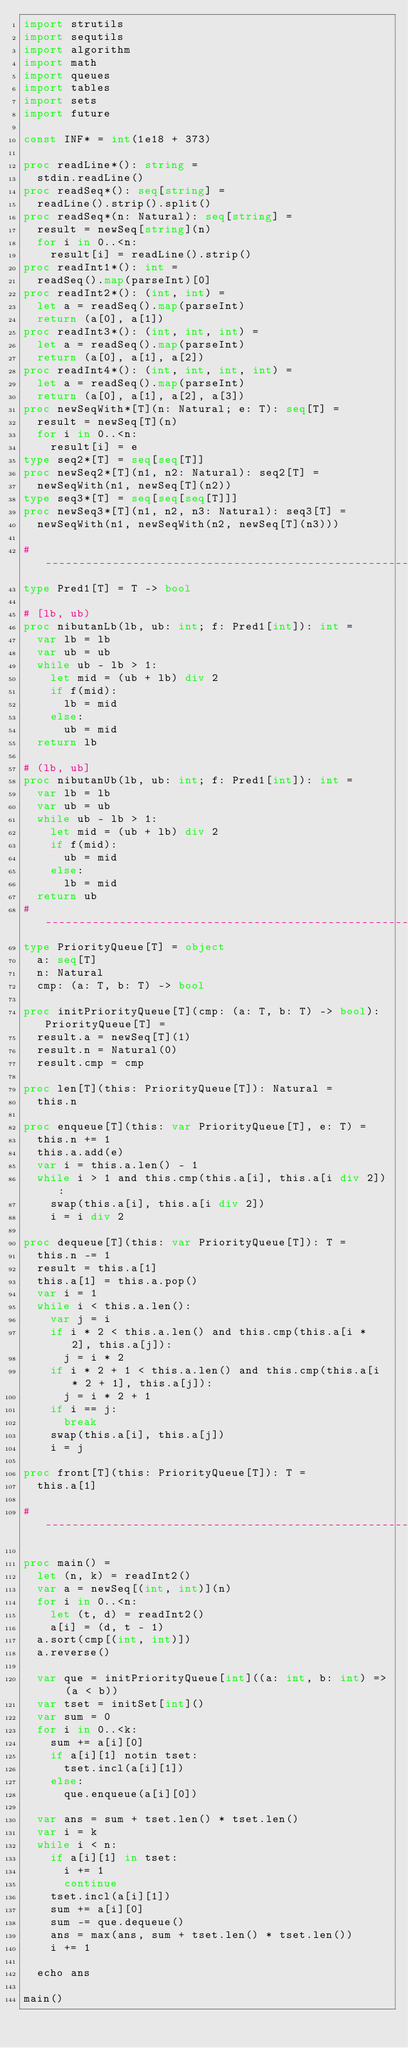<code> <loc_0><loc_0><loc_500><loc_500><_Nim_>import strutils
import sequtils
import algorithm
import math
import queues
import tables
import sets
import future

const INF* = int(1e18 + 373)

proc readLine*(): string =
  stdin.readLine()
proc readSeq*(): seq[string] =
  readLine().strip().split()
proc readSeq*(n: Natural): seq[string] =
  result = newSeq[string](n)
  for i in 0..<n:
    result[i] = readLine().strip()
proc readInt1*(): int =
  readSeq().map(parseInt)[0]
proc readInt2*(): (int, int) =
  let a = readSeq().map(parseInt)
  return (a[0], a[1])
proc readInt3*(): (int, int, int) =
  let a = readSeq().map(parseInt)
  return (a[0], a[1], a[2])
proc readInt4*(): (int, int, int, int) =
  let a = readSeq().map(parseInt)
  return (a[0], a[1], a[2], a[3])
proc newSeqWith*[T](n: Natural; e: T): seq[T] =
  result = newSeq[T](n)
  for i in 0..<n:
    result[i] = e
type seq2*[T] = seq[seq[T]]
proc newSeq2*[T](n1, n2: Natural): seq2[T] =
  newSeqWith(n1, newSeq[T](n2))
type seq3*[T] = seq[seq[seq[T]]]
proc newSeq3*[T](n1, n2, n3: Natural): seq3[T] =
  newSeqWith(n1, newSeqWith(n2, newSeq[T](n3)))

#------------------------------------------------------------------------------#
type Pred1[T] = T -> bool

# [lb, ub)
proc nibutanLb(lb, ub: int; f: Pred1[int]): int =
  var lb = lb
  var ub = ub
  while ub - lb > 1:
    let mid = (ub + lb) div 2
    if f(mid):
      lb = mid
    else:
      ub = mid
  return lb

# (lb, ub]
proc nibutanUb(lb, ub: int; f: Pred1[int]): int =
  var lb = lb
  var ub = ub
  while ub - lb > 1:
    let mid = (ub + lb) div 2
    if f(mid):
      ub = mid
    else:
      lb = mid
  return ub
#------------------------------------------------------------------------------#
type PriorityQueue[T] = object
  a: seq[T]
  n: Natural
  cmp: (a: T, b: T) -> bool

proc initPriorityQueue[T](cmp: (a: T, b: T) -> bool): PriorityQueue[T] =
  result.a = newSeq[T](1)
  result.n = Natural(0)
  result.cmp = cmp

proc len[T](this: PriorityQueue[T]): Natural =
  this.n

proc enqueue[T](this: var PriorityQueue[T], e: T) =
  this.n += 1
  this.a.add(e)
  var i = this.a.len() - 1
  while i > 1 and this.cmp(this.a[i], this.a[i div 2]):
    swap(this.a[i], this.a[i div 2])
    i = i div 2

proc dequeue[T](this: var PriorityQueue[T]): T =
  this.n -= 1
  result = this.a[1]
  this.a[1] = this.a.pop()
  var i = 1
  while i < this.a.len():
    var j = i
    if i * 2 < this.a.len() and this.cmp(this.a[i * 2], this.a[j]):
      j = i * 2
    if i * 2 + 1 < this.a.len() and this.cmp(this.a[i * 2 + 1], this.a[j]):
      j = i * 2 + 1
    if i == j:
      break
    swap(this.a[i], this.a[j])
    i = j

proc front[T](this: PriorityQueue[T]): T =
  this.a[1]

#------------------------------------------------------------------------------#

proc main() =
  let (n, k) = readInt2()
  var a = newSeq[(int, int)](n)
  for i in 0..<n:
    let (t, d) = readInt2()
    a[i] = (d, t - 1)
  a.sort(cmp[(int, int)])
  a.reverse()

  var que = initPriorityQueue[int]((a: int, b: int) => (a < b))
  var tset = initSet[int]()
  var sum = 0
  for i in 0..<k:
    sum += a[i][0]
    if a[i][1] notin tset:
      tset.incl(a[i][1])
    else:
      que.enqueue(a[i][0])

  var ans = sum + tset.len() * tset.len()
  var i = k
  while i < n:
    if a[i][1] in tset:
      i += 1
      continue
    tset.incl(a[i][1])
    sum += a[i][0]
    sum -= que.dequeue()
    ans = max(ans, sum + tset.len() * tset.len())
    i += 1

  echo ans

main()

</code> 